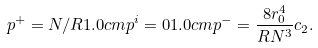<formula> <loc_0><loc_0><loc_500><loc_500>p ^ { + } = N / R 1 . 0 c m p ^ { i } = 0 1 . 0 c m p ^ { - } = \frac { 8 r _ { 0 } ^ { 4 } } { R N ^ { 3 } } c _ { 2 } .</formula> 